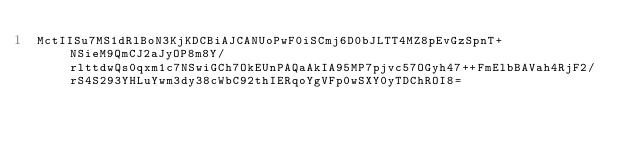Convert code to text. <code><loc_0><loc_0><loc_500><loc_500><_SML_>MctIISu7MS1dRlBoN3KjKDCBiAJCANUoPwF0iSCmj6D0bJLTT4MZ8pEvGzSpnT+NSieM9QmCJ2aJyOP8m8Y/rlttdwQs0qxm1c7NSwiGCh7OkEUnPAQaAkIA95MP7pjvc57OGyh47++FmElbBAVah4RjF2/rS4S293YHLuYwm3dy38cWbC92thIERqoYgVFp0wSXY0yTDChROI8=</code> 